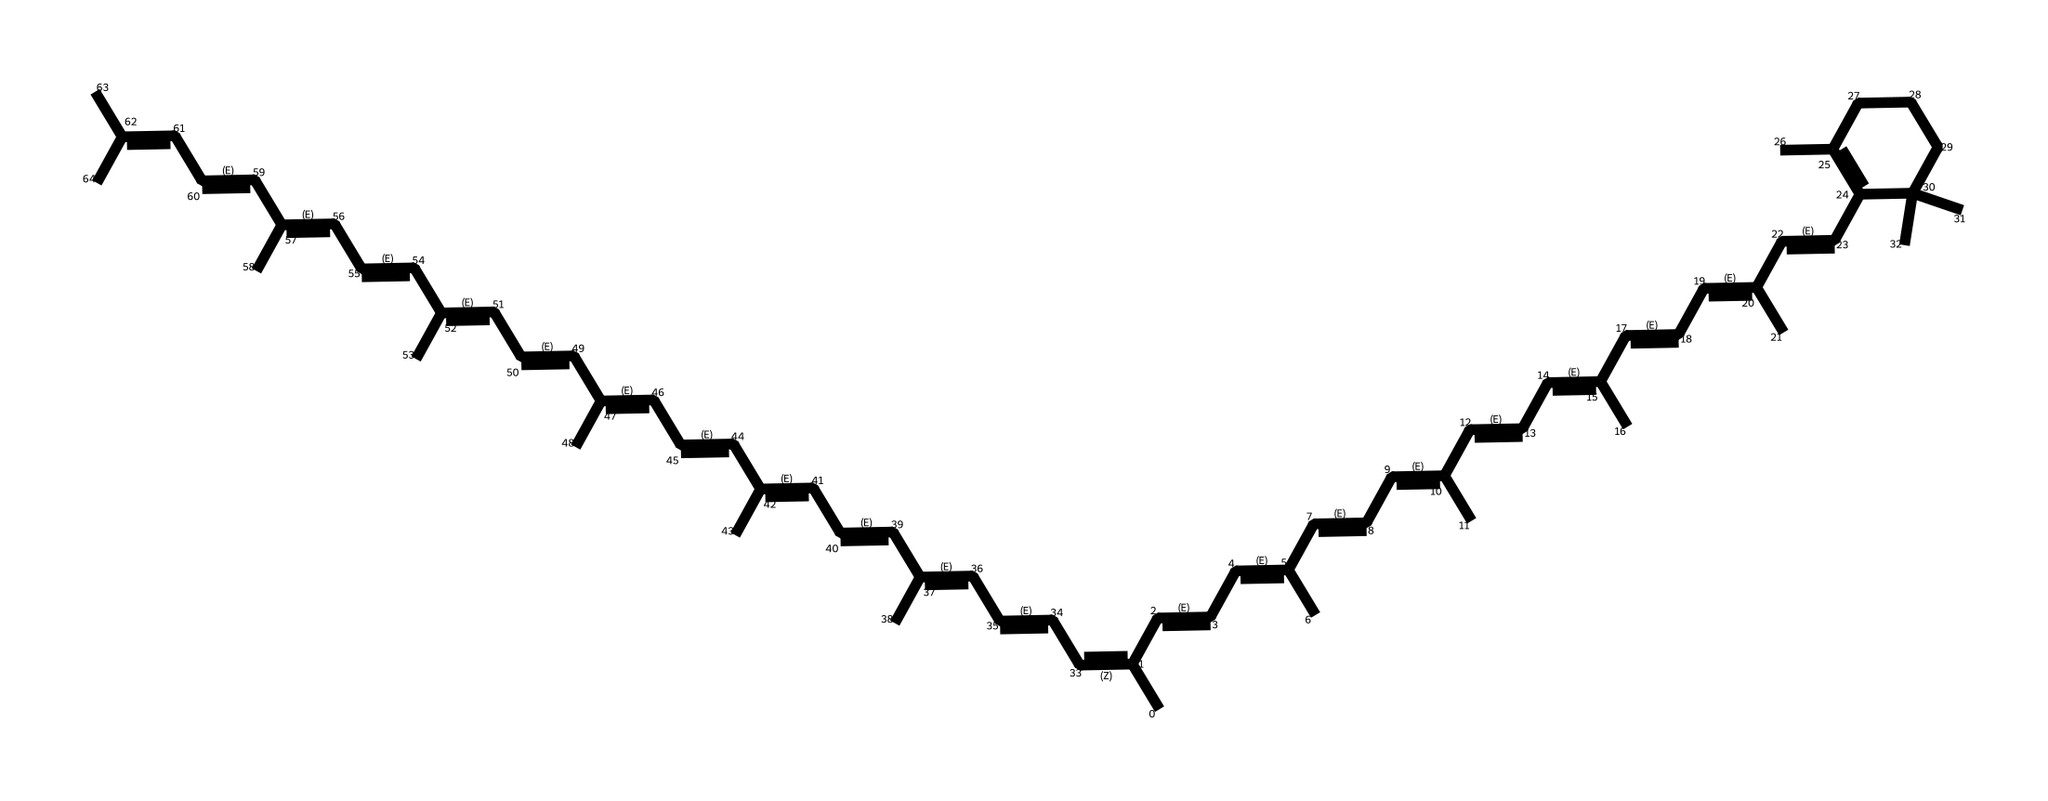What is the name of this chemical? The chemical is lycopene. It is recognized as a carotenoid, which are organic pigments found in plants, responsible for the red color in tomatoes.
Answer: lycopene How many carbon atoms are in the structure? By counting the 'C' in the SMILES representation, a total of 40 carbon atoms can be determined. Each 'C' indicates a carbon atom within the structure.
Answer: 40 How many double bonds are present in the chemical? The structure contains 10 double bonds, represented by the '=' sign in the SMILES notation, indicating where carbon atoms are double-bonded to each other.
Answer: 10 What type of antioxidants does lycopene belong to? Lycopene is classified as a carotenoid, which is a type of antioxidant found in various fruits and vegetables, particularly rich in tomatoes.
Answer: carotenoid Is this compound soluble in water? No, lycopene is hydrophobic, meaning it does not dissolve well in water due to its long hydrocarbon chain and structural properties that favor fat solubility instead.
Answer: No How does lycopene affect oxidative stress in the body? Lycopene reduces oxidative stress primarily through its ability to neutralize free radicals, which can lead to cellular damage. This interaction protects the body's cells and supports overall health.
Answer: reduces oxidative stress 